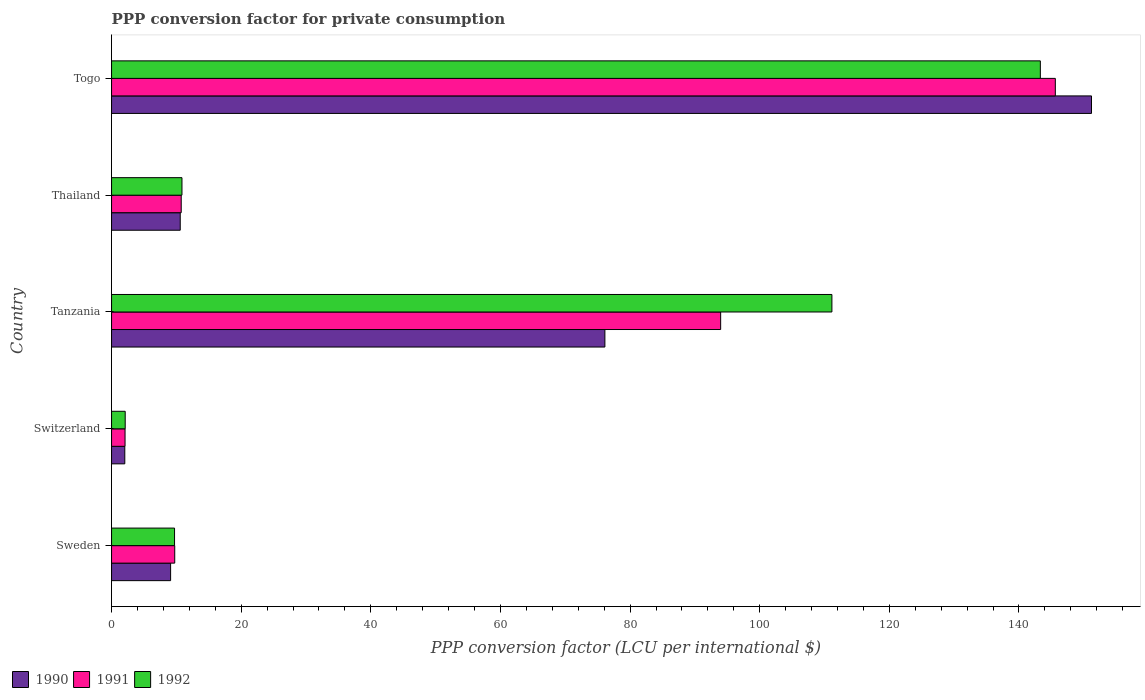How many groups of bars are there?
Your response must be concise. 5. Are the number of bars per tick equal to the number of legend labels?
Make the answer very short. Yes. Are the number of bars on each tick of the Y-axis equal?
Ensure brevity in your answer.  Yes. What is the label of the 2nd group of bars from the top?
Keep it short and to the point. Thailand. In how many cases, is the number of bars for a given country not equal to the number of legend labels?
Ensure brevity in your answer.  0. What is the PPP conversion factor for private consumption in 1991 in Togo?
Offer a terse response. 145.61. Across all countries, what is the maximum PPP conversion factor for private consumption in 1991?
Provide a succinct answer. 145.61. Across all countries, what is the minimum PPP conversion factor for private consumption in 1991?
Provide a succinct answer. 2.08. In which country was the PPP conversion factor for private consumption in 1992 maximum?
Provide a succinct answer. Togo. In which country was the PPP conversion factor for private consumption in 1992 minimum?
Provide a short and direct response. Switzerland. What is the total PPP conversion factor for private consumption in 1992 in the graph?
Your response must be concise. 277.12. What is the difference between the PPP conversion factor for private consumption in 1991 in Sweden and that in Togo?
Your response must be concise. -135.86. What is the difference between the PPP conversion factor for private consumption in 1992 in Switzerland and the PPP conversion factor for private consumption in 1991 in Tanzania?
Your answer should be compact. -91.87. What is the average PPP conversion factor for private consumption in 1991 per country?
Your answer should be compact. 52.43. What is the difference between the PPP conversion factor for private consumption in 1991 and PPP conversion factor for private consumption in 1992 in Tanzania?
Keep it short and to the point. -17.16. What is the ratio of the PPP conversion factor for private consumption in 1991 in Tanzania to that in Thailand?
Give a very brief answer. 8.74. Is the PPP conversion factor for private consumption in 1992 in Tanzania less than that in Togo?
Offer a terse response. Yes. Is the difference between the PPP conversion factor for private consumption in 1991 in Sweden and Togo greater than the difference between the PPP conversion factor for private consumption in 1992 in Sweden and Togo?
Offer a terse response. No. What is the difference between the highest and the second highest PPP conversion factor for private consumption in 1990?
Offer a terse response. 75.08. What is the difference between the highest and the lowest PPP conversion factor for private consumption in 1992?
Give a very brief answer. 141.19. In how many countries, is the PPP conversion factor for private consumption in 1990 greater than the average PPP conversion factor for private consumption in 1990 taken over all countries?
Your answer should be compact. 2. What does the 1st bar from the top in Togo represents?
Your answer should be compact. 1992. What does the 3rd bar from the bottom in Thailand represents?
Provide a short and direct response. 1992. How many bars are there?
Provide a succinct answer. 15. Where does the legend appear in the graph?
Give a very brief answer. Bottom left. What is the title of the graph?
Your response must be concise. PPP conversion factor for private consumption. Does "1971" appear as one of the legend labels in the graph?
Make the answer very short. No. What is the label or title of the X-axis?
Provide a short and direct response. PPP conversion factor (LCU per international $). What is the label or title of the Y-axis?
Provide a succinct answer. Country. What is the PPP conversion factor (LCU per international $) in 1990 in Sweden?
Your answer should be compact. 9.11. What is the PPP conversion factor (LCU per international $) of 1991 in Sweden?
Offer a very short reply. 9.75. What is the PPP conversion factor (LCU per international $) of 1992 in Sweden?
Ensure brevity in your answer.  9.72. What is the PPP conversion factor (LCU per international $) of 1990 in Switzerland?
Provide a short and direct response. 2.04. What is the PPP conversion factor (LCU per international $) in 1991 in Switzerland?
Provide a short and direct response. 2.08. What is the PPP conversion factor (LCU per international $) of 1992 in Switzerland?
Provide a succinct answer. 2.11. What is the PPP conversion factor (LCU per international $) in 1990 in Tanzania?
Give a very brief answer. 76.11. What is the PPP conversion factor (LCU per international $) in 1991 in Tanzania?
Your answer should be compact. 93.97. What is the PPP conversion factor (LCU per international $) of 1992 in Tanzania?
Provide a short and direct response. 111.14. What is the PPP conversion factor (LCU per international $) in 1990 in Thailand?
Keep it short and to the point. 10.6. What is the PPP conversion factor (LCU per international $) in 1991 in Thailand?
Provide a short and direct response. 10.75. What is the PPP conversion factor (LCU per international $) in 1992 in Thailand?
Your response must be concise. 10.86. What is the PPP conversion factor (LCU per international $) in 1990 in Togo?
Your answer should be very brief. 151.19. What is the PPP conversion factor (LCU per international $) of 1991 in Togo?
Offer a terse response. 145.61. What is the PPP conversion factor (LCU per international $) in 1992 in Togo?
Keep it short and to the point. 143.3. Across all countries, what is the maximum PPP conversion factor (LCU per international $) in 1990?
Offer a very short reply. 151.19. Across all countries, what is the maximum PPP conversion factor (LCU per international $) of 1991?
Offer a terse response. 145.61. Across all countries, what is the maximum PPP conversion factor (LCU per international $) in 1992?
Give a very brief answer. 143.3. Across all countries, what is the minimum PPP conversion factor (LCU per international $) of 1990?
Make the answer very short. 2.04. Across all countries, what is the minimum PPP conversion factor (LCU per international $) of 1991?
Offer a terse response. 2.08. Across all countries, what is the minimum PPP conversion factor (LCU per international $) of 1992?
Offer a very short reply. 2.11. What is the total PPP conversion factor (LCU per international $) in 1990 in the graph?
Offer a terse response. 249.05. What is the total PPP conversion factor (LCU per international $) of 1991 in the graph?
Make the answer very short. 262.16. What is the total PPP conversion factor (LCU per international $) of 1992 in the graph?
Provide a succinct answer. 277.12. What is the difference between the PPP conversion factor (LCU per international $) of 1990 in Sweden and that in Switzerland?
Make the answer very short. 7.07. What is the difference between the PPP conversion factor (LCU per international $) in 1991 in Sweden and that in Switzerland?
Offer a terse response. 7.66. What is the difference between the PPP conversion factor (LCU per international $) of 1992 in Sweden and that in Switzerland?
Offer a very short reply. 7.61. What is the difference between the PPP conversion factor (LCU per international $) of 1990 in Sweden and that in Tanzania?
Your answer should be compact. -67. What is the difference between the PPP conversion factor (LCU per international $) in 1991 in Sweden and that in Tanzania?
Provide a succinct answer. -84.23. What is the difference between the PPP conversion factor (LCU per international $) of 1992 in Sweden and that in Tanzania?
Give a very brief answer. -101.42. What is the difference between the PPP conversion factor (LCU per international $) of 1990 in Sweden and that in Thailand?
Make the answer very short. -1.49. What is the difference between the PPP conversion factor (LCU per international $) of 1991 in Sweden and that in Thailand?
Provide a short and direct response. -1. What is the difference between the PPP conversion factor (LCU per international $) of 1992 in Sweden and that in Thailand?
Your response must be concise. -1.15. What is the difference between the PPP conversion factor (LCU per international $) of 1990 in Sweden and that in Togo?
Give a very brief answer. -142.08. What is the difference between the PPP conversion factor (LCU per international $) of 1991 in Sweden and that in Togo?
Offer a very short reply. -135.86. What is the difference between the PPP conversion factor (LCU per international $) of 1992 in Sweden and that in Togo?
Offer a very short reply. -133.58. What is the difference between the PPP conversion factor (LCU per international $) in 1990 in Switzerland and that in Tanzania?
Ensure brevity in your answer.  -74.07. What is the difference between the PPP conversion factor (LCU per international $) in 1991 in Switzerland and that in Tanzania?
Your response must be concise. -91.89. What is the difference between the PPP conversion factor (LCU per international $) of 1992 in Switzerland and that in Tanzania?
Make the answer very short. -109.03. What is the difference between the PPP conversion factor (LCU per international $) in 1990 in Switzerland and that in Thailand?
Your answer should be very brief. -8.55. What is the difference between the PPP conversion factor (LCU per international $) in 1991 in Switzerland and that in Thailand?
Keep it short and to the point. -8.66. What is the difference between the PPP conversion factor (LCU per international $) of 1992 in Switzerland and that in Thailand?
Offer a very short reply. -8.76. What is the difference between the PPP conversion factor (LCU per international $) in 1990 in Switzerland and that in Togo?
Make the answer very short. -149.15. What is the difference between the PPP conversion factor (LCU per international $) in 1991 in Switzerland and that in Togo?
Provide a short and direct response. -143.53. What is the difference between the PPP conversion factor (LCU per international $) of 1992 in Switzerland and that in Togo?
Offer a terse response. -141.19. What is the difference between the PPP conversion factor (LCU per international $) in 1990 in Tanzania and that in Thailand?
Offer a very short reply. 65.52. What is the difference between the PPP conversion factor (LCU per international $) of 1991 in Tanzania and that in Thailand?
Your answer should be compact. 83.23. What is the difference between the PPP conversion factor (LCU per international $) in 1992 in Tanzania and that in Thailand?
Provide a short and direct response. 100.28. What is the difference between the PPP conversion factor (LCU per international $) of 1990 in Tanzania and that in Togo?
Provide a short and direct response. -75.08. What is the difference between the PPP conversion factor (LCU per international $) of 1991 in Tanzania and that in Togo?
Make the answer very short. -51.63. What is the difference between the PPP conversion factor (LCU per international $) of 1992 in Tanzania and that in Togo?
Offer a very short reply. -32.16. What is the difference between the PPP conversion factor (LCU per international $) of 1990 in Thailand and that in Togo?
Keep it short and to the point. -140.59. What is the difference between the PPP conversion factor (LCU per international $) of 1991 in Thailand and that in Togo?
Your answer should be compact. -134.86. What is the difference between the PPP conversion factor (LCU per international $) in 1992 in Thailand and that in Togo?
Offer a terse response. -132.43. What is the difference between the PPP conversion factor (LCU per international $) of 1990 in Sweden and the PPP conversion factor (LCU per international $) of 1991 in Switzerland?
Offer a terse response. 7.03. What is the difference between the PPP conversion factor (LCU per international $) in 1990 in Sweden and the PPP conversion factor (LCU per international $) in 1992 in Switzerland?
Your answer should be compact. 7. What is the difference between the PPP conversion factor (LCU per international $) of 1991 in Sweden and the PPP conversion factor (LCU per international $) of 1992 in Switzerland?
Provide a short and direct response. 7.64. What is the difference between the PPP conversion factor (LCU per international $) in 1990 in Sweden and the PPP conversion factor (LCU per international $) in 1991 in Tanzania?
Ensure brevity in your answer.  -84.86. What is the difference between the PPP conversion factor (LCU per international $) of 1990 in Sweden and the PPP conversion factor (LCU per international $) of 1992 in Tanzania?
Make the answer very short. -102.03. What is the difference between the PPP conversion factor (LCU per international $) in 1991 in Sweden and the PPP conversion factor (LCU per international $) in 1992 in Tanzania?
Ensure brevity in your answer.  -101.39. What is the difference between the PPP conversion factor (LCU per international $) of 1990 in Sweden and the PPP conversion factor (LCU per international $) of 1991 in Thailand?
Provide a short and direct response. -1.64. What is the difference between the PPP conversion factor (LCU per international $) of 1990 in Sweden and the PPP conversion factor (LCU per international $) of 1992 in Thailand?
Give a very brief answer. -1.75. What is the difference between the PPP conversion factor (LCU per international $) in 1991 in Sweden and the PPP conversion factor (LCU per international $) in 1992 in Thailand?
Make the answer very short. -1.12. What is the difference between the PPP conversion factor (LCU per international $) of 1990 in Sweden and the PPP conversion factor (LCU per international $) of 1991 in Togo?
Provide a short and direct response. -136.5. What is the difference between the PPP conversion factor (LCU per international $) of 1990 in Sweden and the PPP conversion factor (LCU per international $) of 1992 in Togo?
Your answer should be very brief. -134.19. What is the difference between the PPP conversion factor (LCU per international $) in 1991 in Sweden and the PPP conversion factor (LCU per international $) in 1992 in Togo?
Ensure brevity in your answer.  -133.55. What is the difference between the PPP conversion factor (LCU per international $) in 1990 in Switzerland and the PPP conversion factor (LCU per international $) in 1991 in Tanzania?
Provide a succinct answer. -91.93. What is the difference between the PPP conversion factor (LCU per international $) in 1990 in Switzerland and the PPP conversion factor (LCU per international $) in 1992 in Tanzania?
Offer a very short reply. -109.1. What is the difference between the PPP conversion factor (LCU per international $) of 1991 in Switzerland and the PPP conversion factor (LCU per international $) of 1992 in Tanzania?
Offer a terse response. -109.06. What is the difference between the PPP conversion factor (LCU per international $) in 1990 in Switzerland and the PPP conversion factor (LCU per international $) in 1991 in Thailand?
Your answer should be very brief. -8.7. What is the difference between the PPP conversion factor (LCU per international $) of 1990 in Switzerland and the PPP conversion factor (LCU per international $) of 1992 in Thailand?
Offer a terse response. -8.82. What is the difference between the PPP conversion factor (LCU per international $) of 1991 in Switzerland and the PPP conversion factor (LCU per international $) of 1992 in Thailand?
Make the answer very short. -8.78. What is the difference between the PPP conversion factor (LCU per international $) in 1990 in Switzerland and the PPP conversion factor (LCU per international $) in 1991 in Togo?
Your answer should be compact. -143.57. What is the difference between the PPP conversion factor (LCU per international $) of 1990 in Switzerland and the PPP conversion factor (LCU per international $) of 1992 in Togo?
Make the answer very short. -141.25. What is the difference between the PPP conversion factor (LCU per international $) in 1991 in Switzerland and the PPP conversion factor (LCU per international $) in 1992 in Togo?
Offer a very short reply. -141.22. What is the difference between the PPP conversion factor (LCU per international $) of 1990 in Tanzania and the PPP conversion factor (LCU per international $) of 1991 in Thailand?
Your answer should be very brief. 65.37. What is the difference between the PPP conversion factor (LCU per international $) of 1990 in Tanzania and the PPP conversion factor (LCU per international $) of 1992 in Thailand?
Give a very brief answer. 65.25. What is the difference between the PPP conversion factor (LCU per international $) of 1991 in Tanzania and the PPP conversion factor (LCU per international $) of 1992 in Thailand?
Make the answer very short. 83.11. What is the difference between the PPP conversion factor (LCU per international $) of 1990 in Tanzania and the PPP conversion factor (LCU per international $) of 1991 in Togo?
Provide a succinct answer. -69.49. What is the difference between the PPP conversion factor (LCU per international $) in 1990 in Tanzania and the PPP conversion factor (LCU per international $) in 1992 in Togo?
Your answer should be compact. -67.18. What is the difference between the PPP conversion factor (LCU per international $) of 1991 in Tanzania and the PPP conversion factor (LCU per international $) of 1992 in Togo?
Provide a succinct answer. -49.32. What is the difference between the PPP conversion factor (LCU per international $) of 1990 in Thailand and the PPP conversion factor (LCU per international $) of 1991 in Togo?
Make the answer very short. -135.01. What is the difference between the PPP conversion factor (LCU per international $) of 1990 in Thailand and the PPP conversion factor (LCU per international $) of 1992 in Togo?
Provide a succinct answer. -132.7. What is the difference between the PPP conversion factor (LCU per international $) in 1991 in Thailand and the PPP conversion factor (LCU per international $) in 1992 in Togo?
Provide a succinct answer. -132.55. What is the average PPP conversion factor (LCU per international $) of 1990 per country?
Ensure brevity in your answer.  49.81. What is the average PPP conversion factor (LCU per international $) of 1991 per country?
Offer a terse response. 52.43. What is the average PPP conversion factor (LCU per international $) in 1992 per country?
Your response must be concise. 55.42. What is the difference between the PPP conversion factor (LCU per international $) in 1990 and PPP conversion factor (LCU per international $) in 1991 in Sweden?
Your response must be concise. -0.64. What is the difference between the PPP conversion factor (LCU per international $) of 1990 and PPP conversion factor (LCU per international $) of 1992 in Sweden?
Your response must be concise. -0.61. What is the difference between the PPP conversion factor (LCU per international $) of 1991 and PPP conversion factor (LCU per international $) of 1992 in Sweden?
Your response must be concise. 0.03. What is the difference between the PPP conversion factor (LCU per international $) of 1990 and PPP conversion factor (LCU per international $) of 1991 in Switzerland?
Keep it short and to the point. -0.04. What is the difference between the PPP conversion factor (LCU per international $) of 1990 and PPP conversion factor (LCU per international $) of 1992 in Switzerland?
Provide a succinct answer. -0.06. What is the difference between the PPP conversion factor (LCU per international $) in 1991 and PPP conversion factor (LCU per international $) in 1992 in Switzerland?
Your answer should be compact. -0.02. What is the difference between the PPP conversion factor (LCU per international $) in 1990 and PPP conversion factor (LCU per international $) in 1991 in Tanzania?
Provide a succinct answer. -17.86. What is the difference between the PPP conversion factor (LCU per international $) of 1990 and PPP conversion factor (LCU per international $) of 1992 in Tanzania?
Keep it short and to the point. -35.03. What is the difference between the PPP conversion factor (LCU per international $) in 1991 and PPP conversion factor (LCU per international $) in 1992 in Tanzania?
Your response must be concise. -17.16. What is the difference between the PPP conversion factor (LCU per international $) of 1990 and PPP conversion factor (LCU per international $) of 1991 in Thailand?
Your answer should be compact. -0.15. What is the difference between the PPP conversion factor (LCU per international $) in 1990 and PPP conversion factor (LCU per international $) in 1992 in Thailand?
Give a very brief answer. -0.27. What is the difference between the PPP conversion factor (LCU per international $) in 1991 and PPP conversion factor (LCU per international $) in 1992 in Thailand?
Make the answer very short. -0.12. What is the difference between the PPP conversion factor (LCU per international $) in 1990 and PPP conversion factor (LCU per international $) in 1991 in Togo?
Provide a short and direct response. 5.58. What is the difference between the PPP conversion factor (LCU per international $) of 1990 and PPP conversion factor (LCU per international $) of 1992 in Togo?
Offer a terse response. 7.89. What is the difference between the PPP conversion factor (LCU per international $) of 1991 and PPP conversion factor (LCU per international $) of 1992 in Togo?
Provide a succinct answer. 2.31. What is the ratio of the PPP conversion factor (LCU per international $) in 1990 in Sweden to that in Switzerland?
Make the answer very short. 4.46. What is the ratio of the PPP conversion factor (LCU per international $) of 1991 in Sweden to that in Switzerland?
Offer a terse response. 4.68. What is the ratio of the PPP conversion factor (LCU per international $) in 1992 in Sweden to that in Switzerland?
Your answer should be compact. 4.61. What is the ratio of the PPP conversion factor (LCU per international $) in 1990 in Sweden to that in Tanzania?
Provide a short and direct response. 0.12. What is the ratio of the PPP conversion factor (LCU per international $) of 1991 in Sweden to that in Tanzania?
Offer a terse response. 0.1. What is the ratio of the PPP conversion factor (LCU per international $) of 1992 in Sweden to that in Tanzania?
Give a very brief answer. 0.09. What is the ratio of the PPP conversion factor (LCU per international $) of 1990 in Sweden to that in Thailand?
Keep it short and to the point. 0.86. What is the ratio of the PPP conversion factor (LCU per international $) of 1991 in Sweden to that in Thailand?
Keep it short and to the point. 0.91. What is the ratio of the PPP conversion factor (LCU per international $) of 1992 in Sweden to that in Thailand?
Your answer should be very brief. 0.89. What is the ratio of the PPP conversion factor (LCU per international $) in 1990 in Sweden to that in Togo?
Provide a succinct answer. 0.06. What is the ratio of the PPP conversion factor (LCU per international $) in 1991 in Sweden to that in Togo?
Keep it short and to the point. 0.07. What is the ratio of the PPP conversion factor (LCU per international $) in 1992 in Sweden to that in Togo?
Offer a very short reply. 0.07. What is the ratio of the PPP conversion factor (LCU per international $) in 1990 in Switzerland to that in Tanzania?
Offer a terse response. 0.03. What is the ratio of the PPP conversion factor (LCU per international $) of 1991 in Switzerland to that in Tanzania?
Your response must be concise. 0.02. What is the ratio of the PPP conversion factor (LCU per international $) of 1992 in Switzerland to that in Tanzania?
Keep it short and to the point. 0.02. What is the ratio of the PPP conversion factor (LCU per international $) of 1990 in Switzerland to that in Thailand?
Give a very brief answer. 0.19. What is the ratio of the PPP conversion factor (LCU per international $) of 1991 in Switzerland to that in Thailand?
Make the answer very short. 0.19. What is the ratio of the PPP conversion factor (LCU per international $) of 1992 in Switzerland to that in Thailand?
Make the answer very short. 0.19. What is the ratio of the PPP conversion factor (LCU per international $) in 1990 in Switzerland to that in Togo?
Your answer should be very brief. 0.01. What is the ratio of the PPP conversion factor (LCU per international $) in 1991 in Switzerland to that in Togo?
Offer a terse response. 0.01. What is the ratio of the PPP conversion factor (LCU per international $) of 1992 in Switzerland to that in Togo?
Give a very brief answer. 0.01. What is the ratio of the PPP conversion factor (LCU per international $) in 1990 in Tanzania to that in Thailand?
Provide a succinct answer. 7.18. What is the ratio of the PPP conversion factor (LCU per international $) of 1991 in Tanzania to that in Thailand?
Offer a terse response. 8.74. What is the ratio of the PPP conversion factor (LCU per international $) of 1992 in Tanzania to that in Thailand?
Your answer should be compact. 10.23. What is the ratio of the PPP conversion factor (LCU per international $) in 1990 in Tanzania to that in Togo?
Your response must be concise. 0.5. What is the ratio of the PPP conversion factor (LCU per international $) in 1991 in Tanzania to that in Togo?
Offer a very short reply. 0.65. What is the ratio of the PPP conversion factor (LCU per international $) in 1992 in Tanzania to that in Togo?
Your answer should be compact. 0.78. What is the ratio of the PPP conversion factor (LCU per international $) in 1990 in Thailand to that in Togo?
Your answer should be compact. 0.07. What is the ratio of the PPP conversion factor (LCU per international $) in 1991 in Thailand to that in Togo?
Make the answer very short. 0.07. What is the ratio of the PPP conversion factor (LCU per international $) of 1992 in Thailand to that in Togo?
Give a very brief answer. 0.08. What is the difference between the highest and the second highest PPP conversion factor (LCU per international $) of 1990?
Keep it short and to the point. 75.08. What is the difference between the highest and the second highest PPP conversion factor (LCU per international $) of 1991?
Keep it short and to the point. 51.63. What is the difference between the highest and the second highest PPP conversion factor (LCU per international $) in 1992?
Provide a succinct answer. 32.16. What is the difference between the highest and the lowest PPP conversion factor (LCU per international $) of 1990?
Your response must be concise. 149.15. What is the difference between the highest and the lowest PPP conversion factor (LCU per international $) of 1991?
Ensure brevity in your answer.  143.53. What is the difference between the highest and the lowest PPP conversion factor (LCU per international $) of 1992?
Provide a succinct answer. 141.19. 